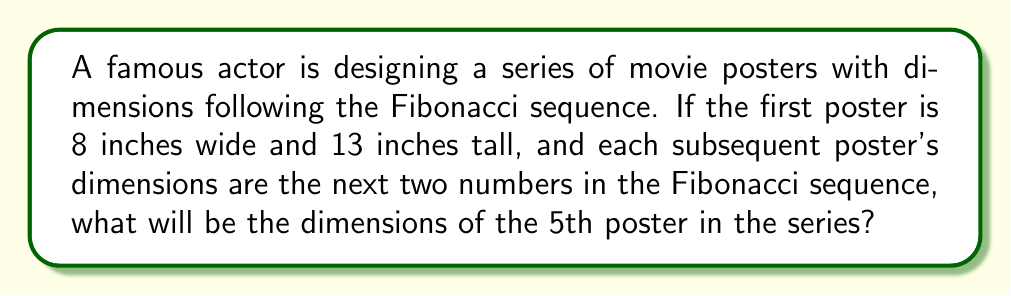Could you help me with this problem? Let's approach this step-by-step:

1) First, recall the Fibonacci sequence: Each number is the sum of the two preceding ones.

2) We're given that the first poster is 8 inches wide and 13 inches tall. These are the 6th and 7th numbers in the Fibonacci sequence.

3) Let's write out the sequence starting from these numbers:
   8, 13, 21, 34, 55, 89, ...

4) Now, let's determine the dimensions of each poster:
   - 1st poster: 8 x 13
   - 2nd poster: 13 x 21
   - 3rd poster: 21 x 34
   - 4th poster: 34 x 55
   - 5th poster: 55 x 89

5) We can verify each step using the Fibonacci recurrence relation:
   $$F_n = F_{n-1} + F_{n-2}$$

   For example, for the 5th poster's height:
   $$89 = 55 + 34$$

Therefore, the dimensions of the 5th poster will be 55 inches wide and 89 inches tall.
Answer: 55 x 89 inches 